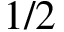Convert formula to latex. <formula><loc_0><loc_0><loc_500><loc_500>1 / 2</formula> 